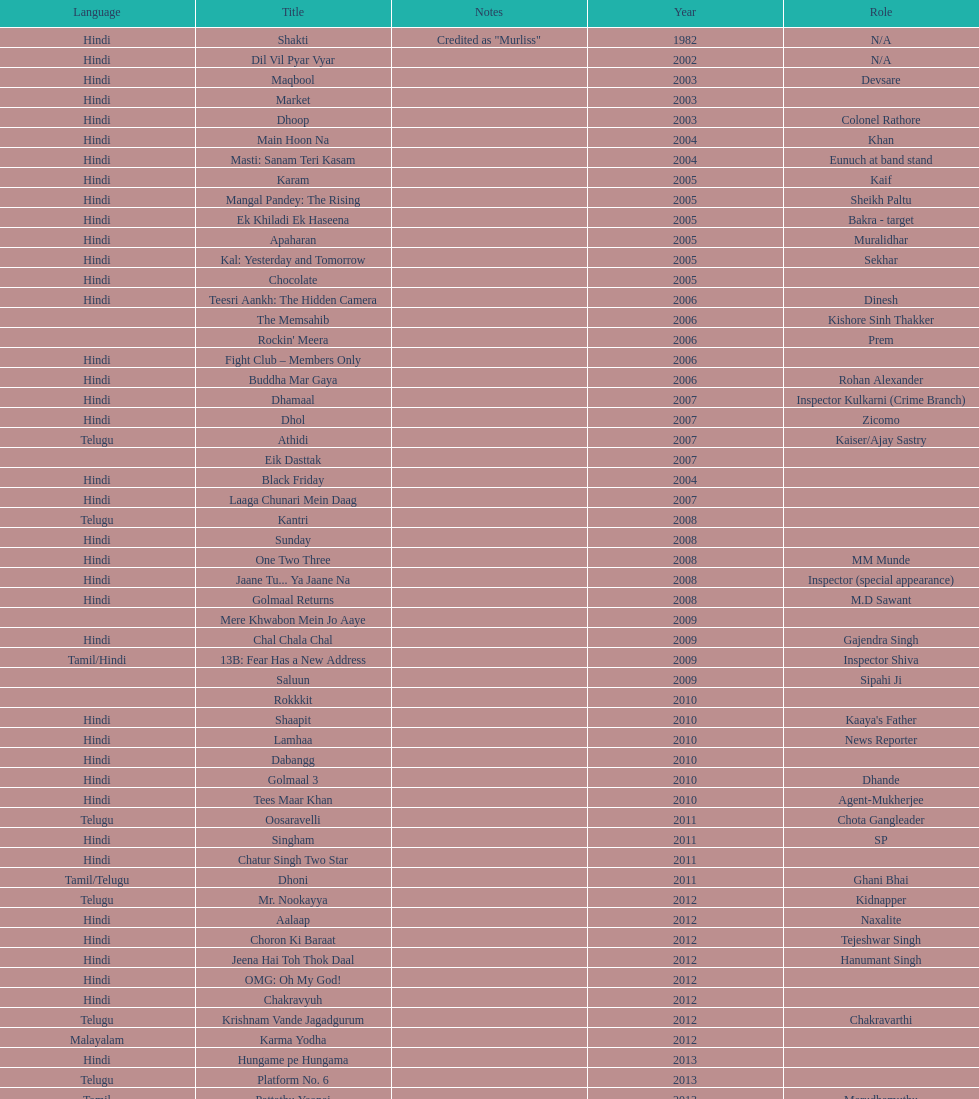Does maqbool have longer notes than shakti? No. 